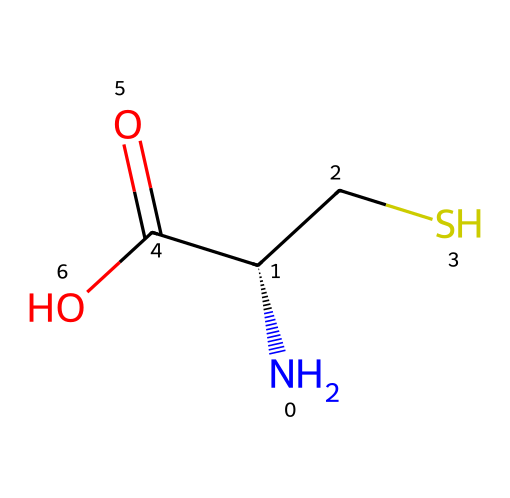What is the main functional group present in cysteine? The SMILES representation shows a thiol (-SH) group, which is characteristic of cysteine. The sulfur atom connected to a hydrogen atom indicates the presence of a thiol functional group.
Answer: thiol How many carbon atoms are in the structure of cysteine? The SMILES representation indicates three carbon atoms: one in the amine group, one in the thiol group, and one in the carboxylic acid group. This is counted directly from the structure.
Answer: three What is the total number of nitrogen atoms in this molecule? The SMILES representation indicates one nitrogen atom in the amino group. This can be identified directly from the structure, where the nitrogen atom is connected to the carbon backbone.
Answer: one Which functional group contributes to cysteine's properties as an organosulfur compound? The presence of the thiol (-SH) functional group is what identifies cysteine as an organosulfur compound, specifically giving it the characteristic properties associated with sulfur chemistry.
Answer: thiol What type of structure does cysteine form in proteins? Cysteine can form disulfide bonds with other cysteine residues through oxidation of the thiol groups. This cross-linking contributes to the stability and structure of proteins.
Answer: disulfide bonds How does the presence of sulfur in cysteine affect its reactivity compared to other amino acids? The sulfur atom in cysteine allows it to participate in redox reactions and form covalent bonds, which is not characteristic of other common amino acids without sulfur. Thus, it is more reactive in certain biochemical contexts.
Answer: increased reactivity 